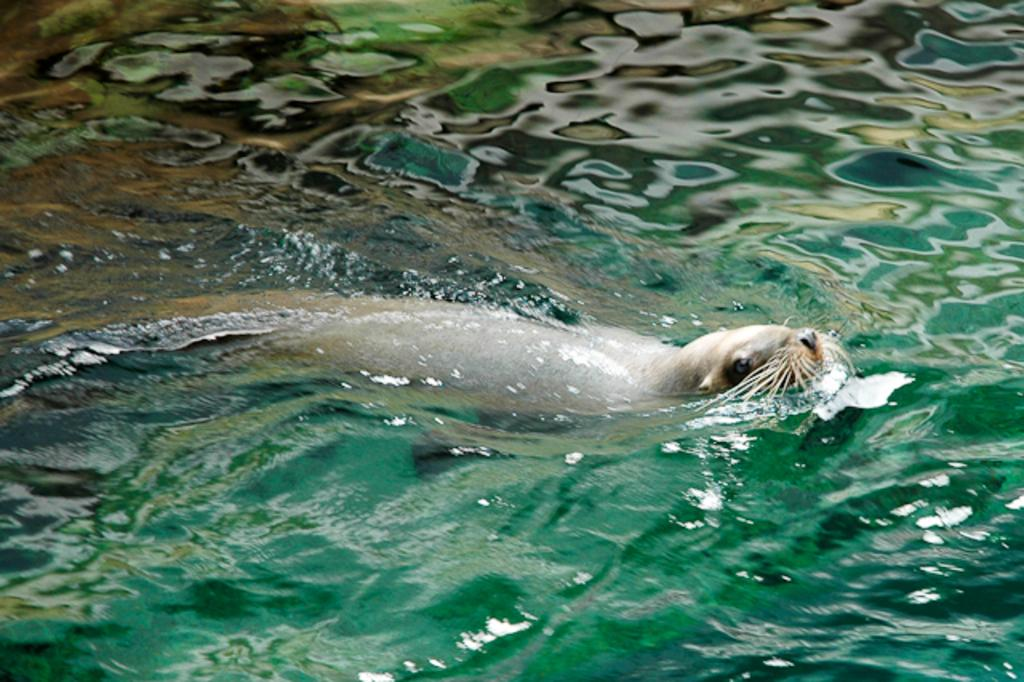What is the primary element in the image? There is water in the image. What type of animal can be seen in the water? A sea lion is present in the water. How many rabbits can be seen jumping over the wall in the image? There are no rabbits or walls present in the image; it features water and a sea lion. 